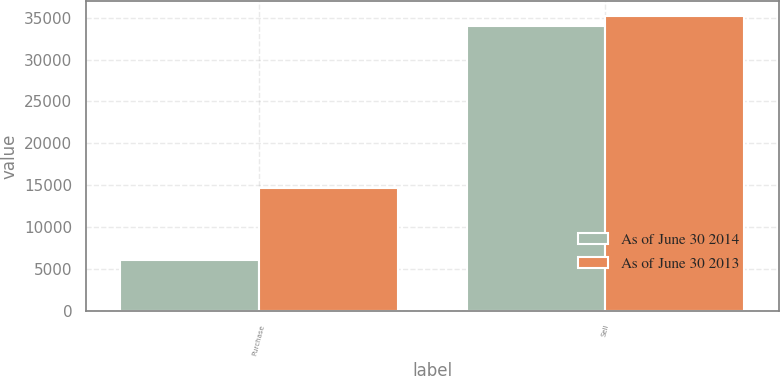Convert chart. <chart><loc_0><loc_0><loc_500><loc_500><stacked_bar_chart><ecel><fcel>Purchase<fcel>Sell<nl><fcel>As of June 30 2014<fcel>6066<fcel>33999<nl><fcel>As of June 30 2013<fcel>14641<fcel>35178<nl></chart> 